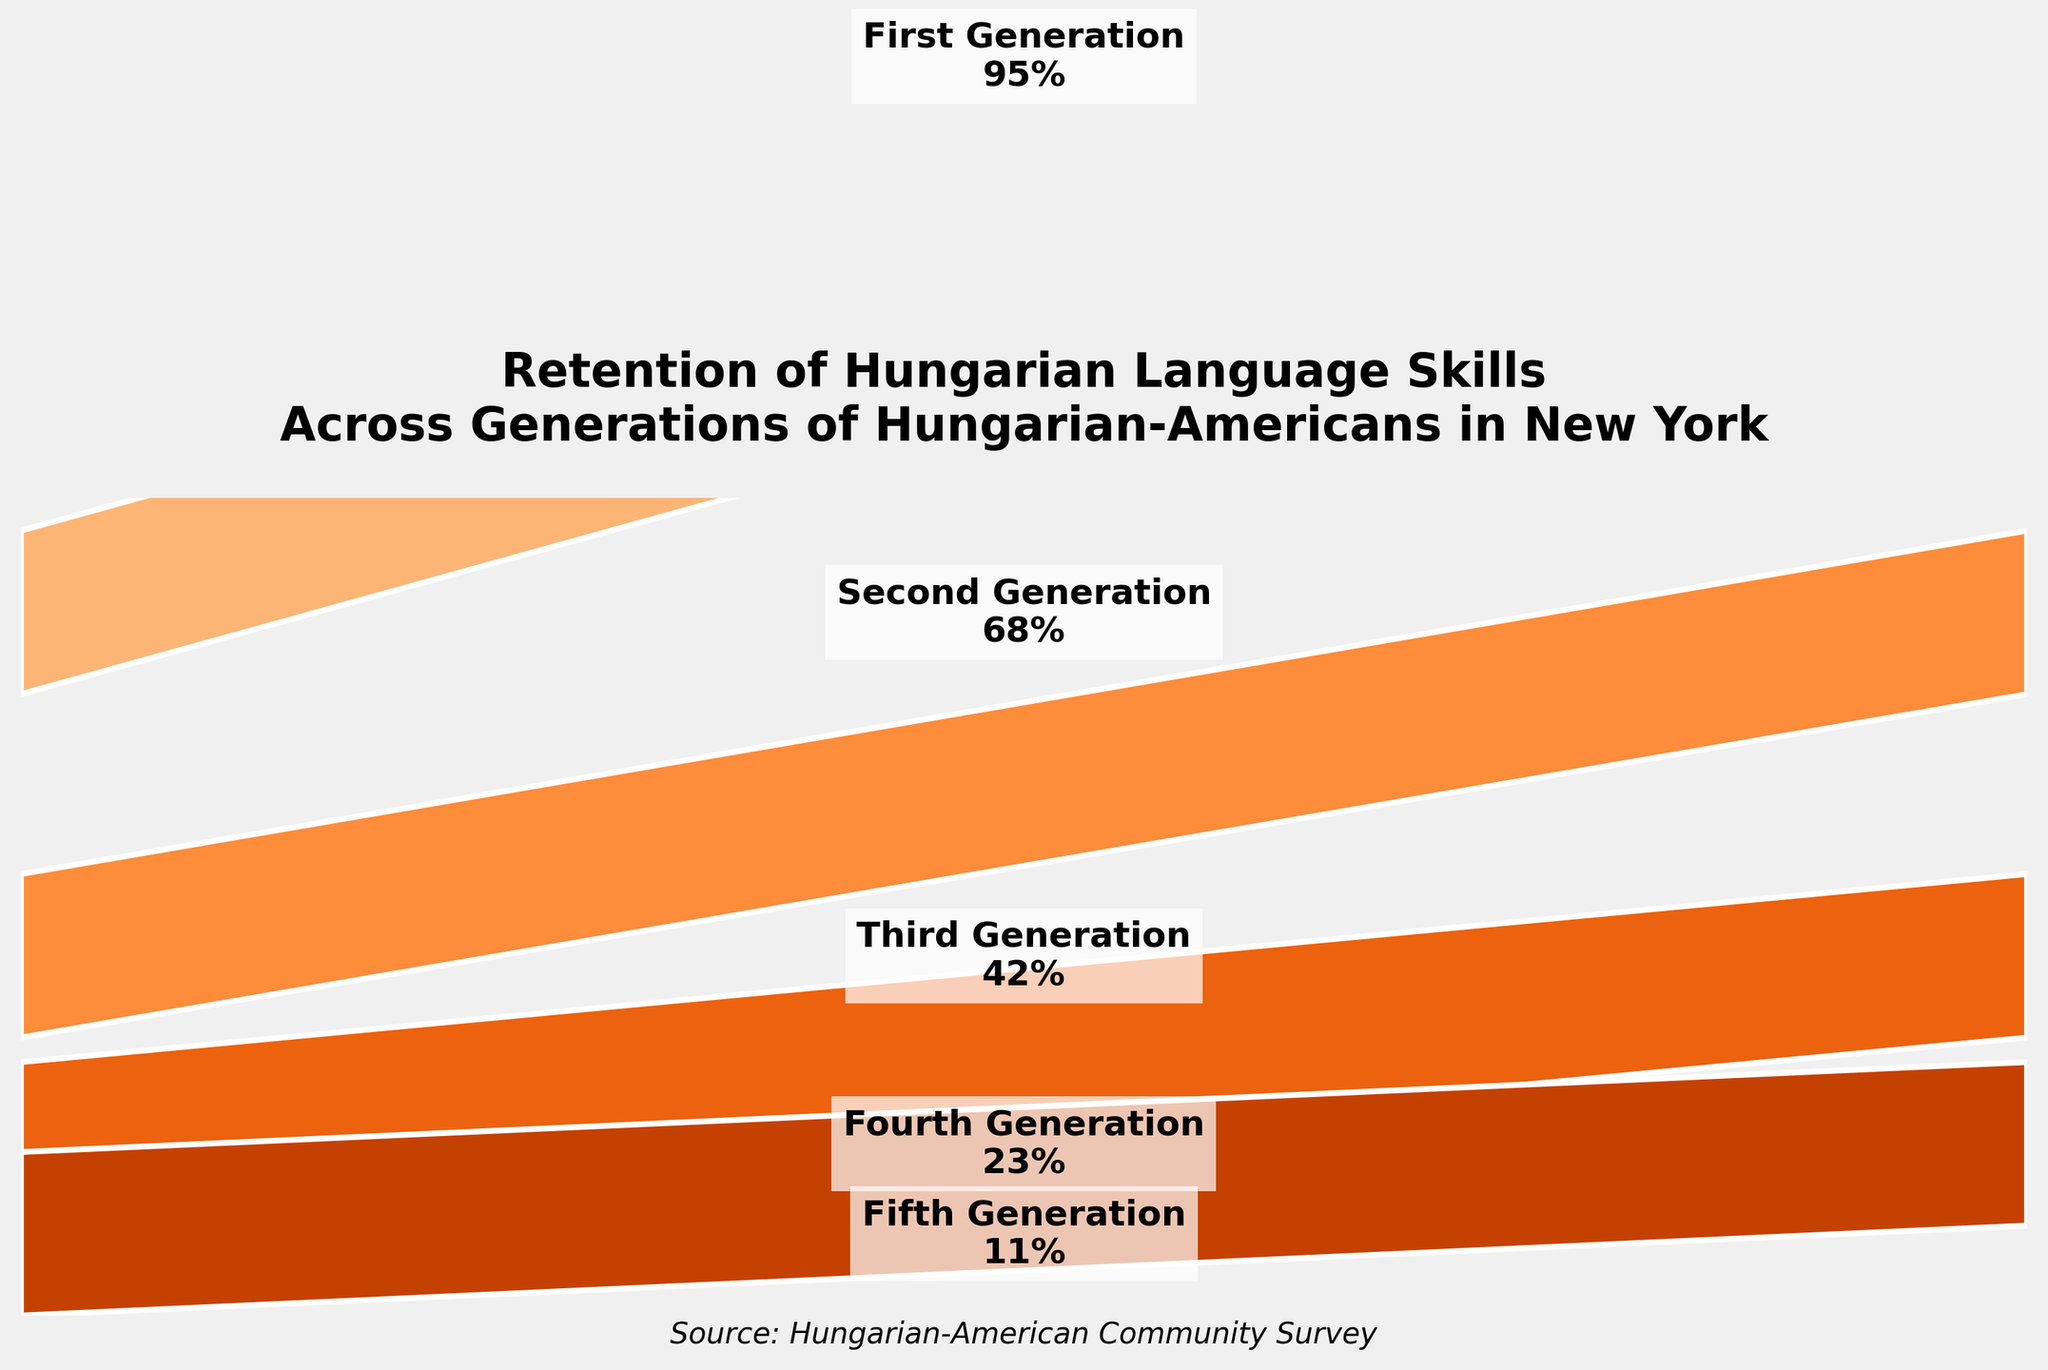What is the retention rate for the second generation? The second generation section notes a retention rate of 68% for Hungarian language skills.
Answer: 68% How does the retention rate change from the first to the second generation? The retention rate decreases from 95% in the first generation to 68% in the second generation, resulting in a decrease of 95% - 68% = 27%.
Answer: 27% decrease Which generation has the lowest retention rate? The fifth generation has the lowest retention rate, which is indicated as 11% in the funnel chart.
Answer: Fifth generation How much does the retention rate decrease from the third to the fourth generation? The retention rate decreases from 42% in the third generation to 23% in the fourth generation, which is a difference of 42% - 23% = 19%.
Answer: 19% What is the average retention rate across all generations? To find the average retention rate, sum all the percentages and then divide by the number of generations: (95% + 68% + 42% + 23% + 11%) / 5 = 239% / 5 = 47.8%.
Answer: 47.8% How does the size of each stage in the funnel visually change from the first generation to the fifth generation? The size of the stage representing each subsequent generation decreases, showing narrower segments from first to fifth generation, indicating a reducing retention rate for Hungarian language skills across generations.
Answer: Narrows down gradually What is the total percentage drop from the first generation to the fifth generation? The total percentage drop is calculated by subtracting the fifth generation retention rate from the first generation retention rate: 95% - 11% = 84%.
Answer: 84% Which generation shows the largest single drop in retention rates compared to the previous one? The largest single drop occurs between the first and second generations, where the retention rate drops from 95% to 68%, resulting in a 27% decrease.
Answer: Between first and second generations Considering the current trend, why might it be challenging for Hungarian language skills to persist in further generations? The funnel chart shows a steady decline in retention rates across generations, from a high of 95% in the first generation to 11% in the fifth, suggesting decreasing transmission and adoption of the language over time.
Answer: Steady decline, low adoption How does the data represented in the funnel chart highlight the importance of cultural initiatives in the community? The significant drop in retention rates as shown in the funnel chart accentuates the need for cultural programs and language preservation initiatives to maintain Hungarian language skills within the Hungarian-American community.
Answer: Highlights need for cultural programs 